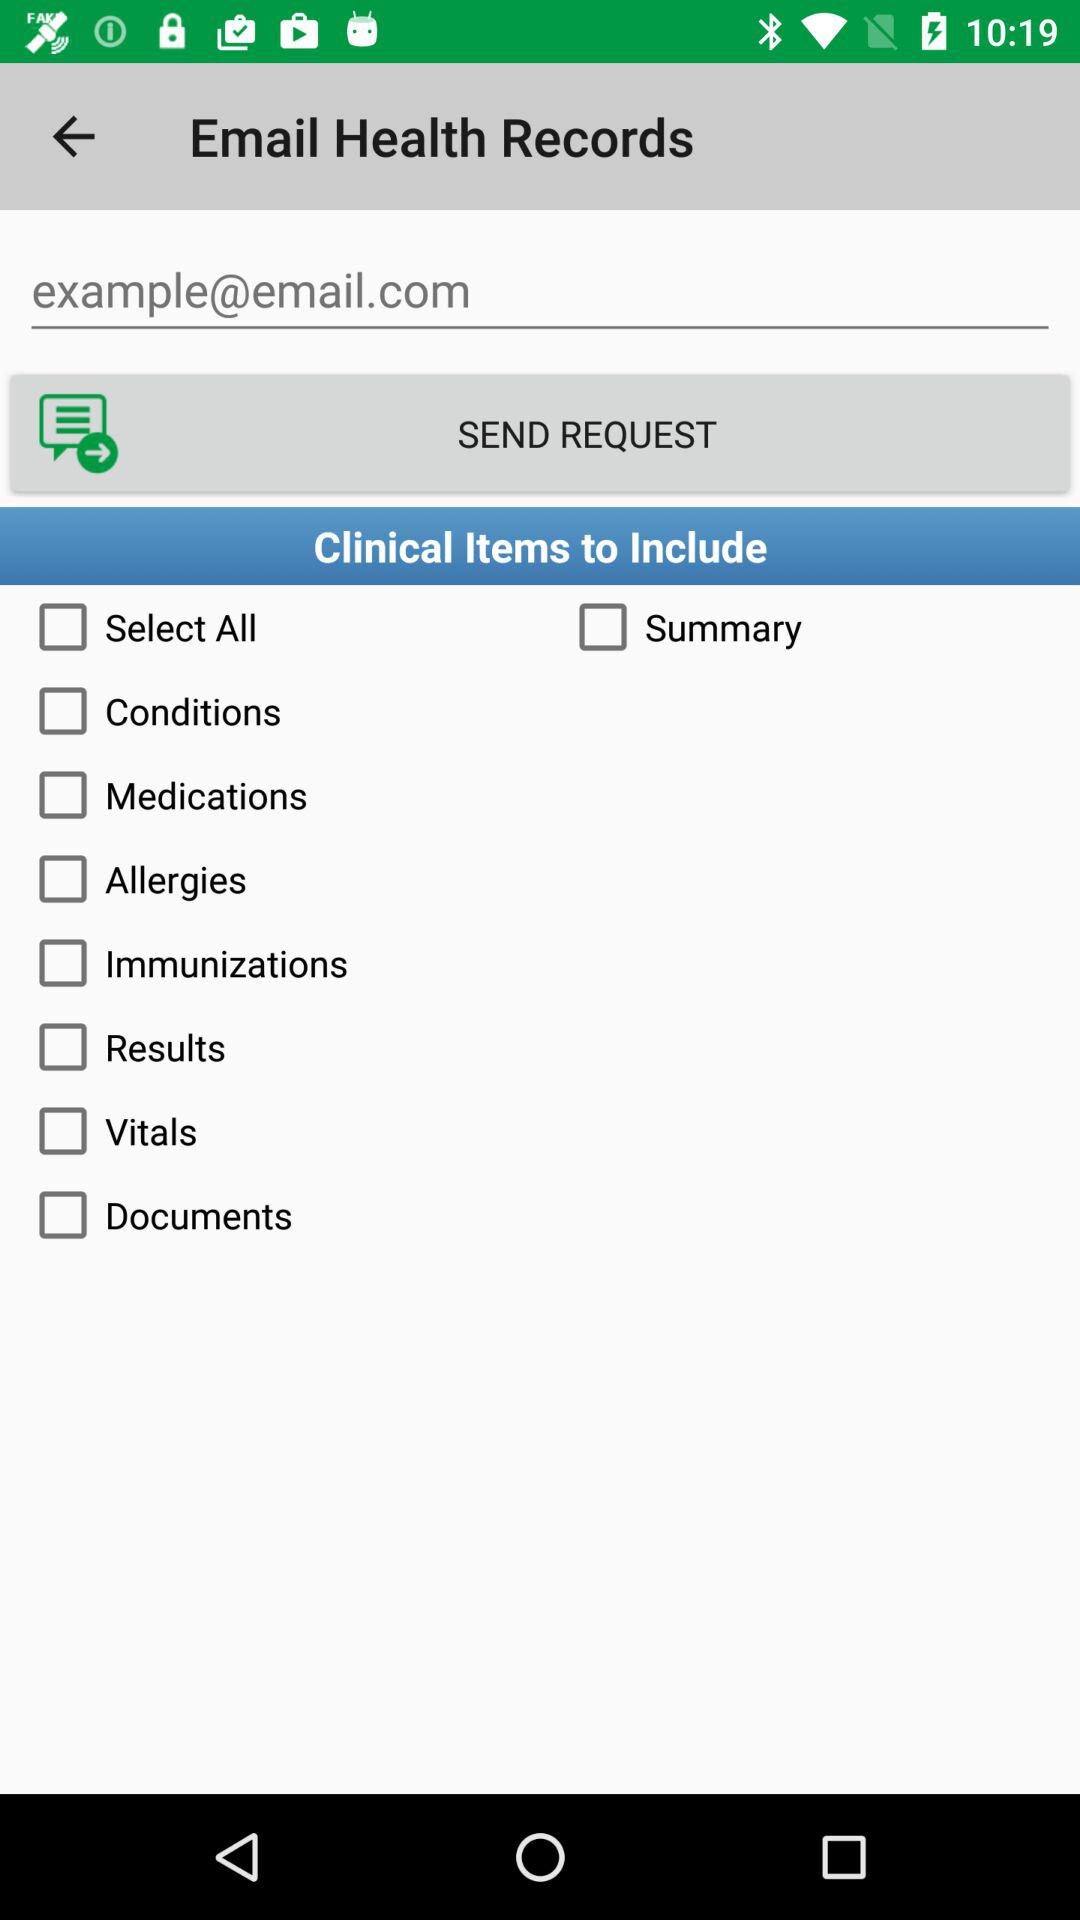What is the email address? The email address is example@email.com. 